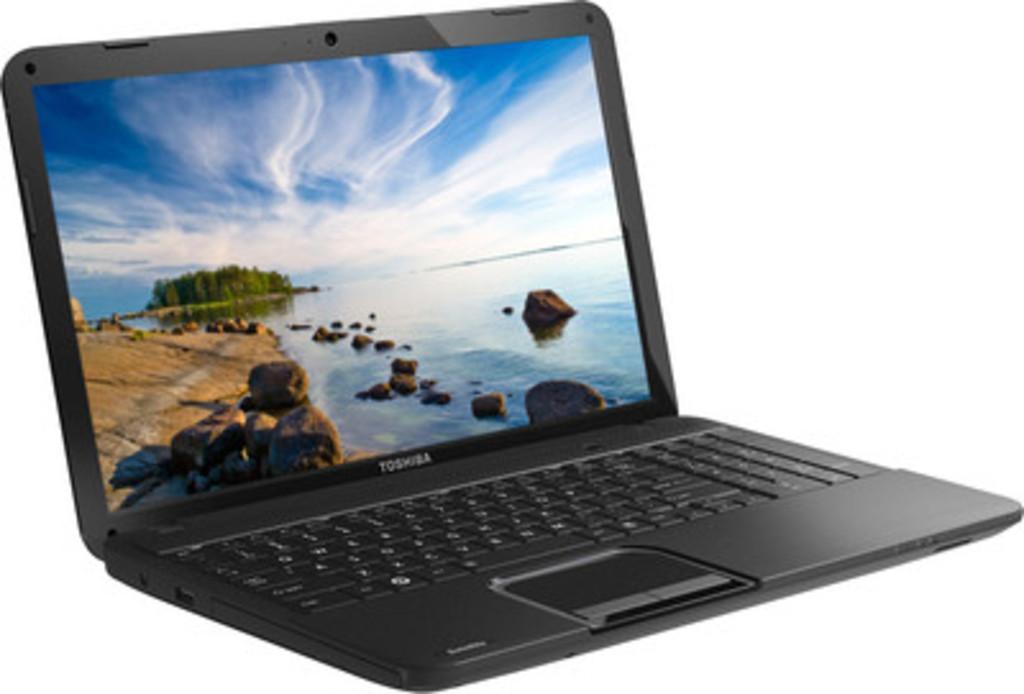Could you give a brief overview of what you see in this image? In the picture there is a black laptop of Toshiba company, the background of the laptop is white color. 